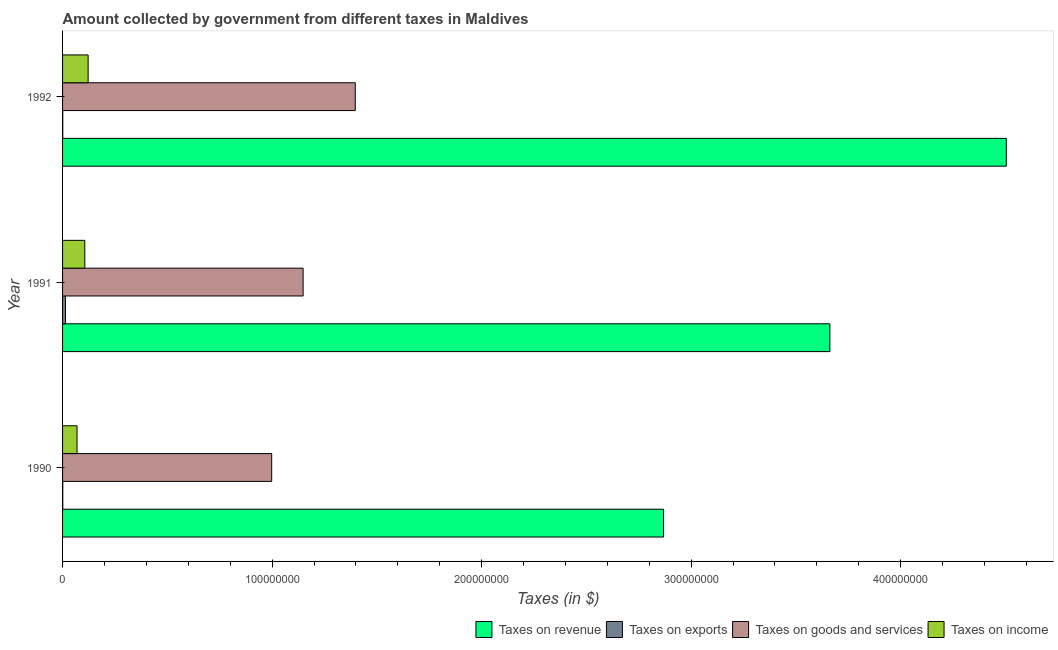How many different coloured bars are there?
Offer a very short reply. 4. How many groups of bars are there?
Your answer should be very brief. 3. Are the number of bars on each tick of the Y-axis equal?
Your answer should be compact. Yes. In how many cases, is the number of bars for a given year not equal to the number of legend labels?
Offer a terse response. 0. What is the amount collected as tax on exports in 1992?
Provide a succinct answer. 1.00e+05. Across all years, what is the maximum amount collected as tax on revenue?
Offer a very short reply. 4.50e+08. Across all years, what is the minimum amount collected as tax on income?
Give a very brief answer. 6.90e+06. What is the total amount collected as tax on revenue in the graph?
Your answer should be very brief. 1.10e+09. What is the difference between the amount collected as tax on goods in 1991 and that in 1992?
Provide a short and direct response. -2.49e+07. What is the difference between the amount collected as tax on revenue in 1991 and the amount collected as tax on income in 1990?
Provide a short and direct response. 3.59e+08. What is the average amount collected as tax on goods per year?
Your answer should be very brief. 1.18e+08. In the year 1992, what is the difference between the amount collected as tax on exports and amount collected as tax on revenue?
Ensure brevity in your answer.  -4.50e+08. In how many years, is the amount collected as tax on exports greater than 260000000 $?
Your answer should be very brief. 0. What is the ratio of the amount collected as tax on goods in 1991 to that in 1992?
Offer a very short reply. 0.82. Is the amount collected as tax on revenue in 1990 less than that in 1991?
Offer a very short reply. Yes. What is the difference between the highest and the second highest amount collected as tax on goods?
Your response must be concise. 2.49e+07. What is the difference between the highest and the lowest amount collected as tax on goods?
Offer a very short reply. 3.99e+07. Is the sum of the amount collected as tax on revenue in 1990 and 1992 greater than the maximum amount collected as tax on goods across all years?
Your answer should be compact. Yes. Is it the case that in every year, the sum of the amount collected as tax on revenue and amount collected as tax on exports is greater than the sum of amount collected as tax on income and amount collected as tax on goods?
Keep it short and to the point. Yes. What does the 2nd bar from the top in 1991 represents?
Your response must be concise. Taxes on goods and services. What does the 3rd bar from the bottom in 1990 represents?
Keep it short and to the point. Taxes on goods and services. Are the values on the major ticks of X-axis written in scientific E-notation?
Offer a terse response. No. Does the graph contain any zero values?
Offer a very short reply. No. Where does the legend appear in the graph?
Offer a terse response. Bottom right. How many legend labels are there?
Offer a terse response. 4. What is the title of the graph?
Give a very brief answer. Amount collected by government from different taxes in Maldives. What is the label or title of the X-axis?
Give a very brief answer. Taxes (in $). What is the Taxes (in $) of Taxes on revenue in 1990?
Keep it short and to the point. 2.87e+08. What is the Taxes (in $) in Taxes on exports in 1990?
Keep it short and to the point. 1.00e+05. What is the Taxes (in $) in Taxes on goods and services in 1990?
Offer a very short reply. 9.98e+07. What is the Taxes (in $) of Taxes on income in 1990?
Keep it short and to the point. 6.90e+06. What is the Taxes (in $) of Taxes on revenue in 1991?
Your answer should be compact. 3.66e+08. What is the Taxes (in $) in Taxes on exports in 1991?
Ensure brevity in your answer.  1.40e+06. What is the Taxes (in $) of Taxes on goods and services in 1991?
Provide a short and direct response. 1.15e+08. What is the Taxes (in $) in Taxes on income in 1991?
Keep it short and to the point. 1.06e+07. What is the Taxes (in $) in Taxes on revenue in 1992?
Your answer should be compact. 4.50e+08. What is the Taxes (in $) of Taxes on goods and services in 1992?
Provide a short and direct response. 1.40e+08. What is the Taxes (in $) of Taxes on income in 1992?
Your response must be concise. 1.22e+07. Across all years, what is the maximum Taxes (in $) of Taxes on revenue?
Make the answer very short. 4.50e+08. Across all years, what is the maximum Taxes (in $) in Taxes on exports?
Provide a short and direct response. 1.40e+06. Across all years, what is the maximum Taxes (in $) in Taxes on goods and services?
Offer a terse response. 1.40e+08. Across all years, what is the maximum Taxes (in $) in Taxes on income?
Provide a succinct answer. 1.22e+07. Across all years, what is the minimum Taxes (in $) of Taxes on revenue?
Offer a very short reply. 2.87e+08. Across all years, what is the minimum Taxes (in $) in Taxes on goods and services?
Make the answer very short. 9.98e+07. Across all years, what is the minimum Taxes (in $) of Taxes on income?
Your answer should be compact. 6.90e+06. What is the total Taxes (in $) in Taxes on revenue in the graph?
Your answer should be very brief. 1.10e+09. What is the total Taxes (in $) in Taxes on exports in the graph?
Offer a very short reply. 1.60e+06. What is the total Taxes (in $) of Taxes on goods and services in the graph?
Make the answer very short. 3.54e+08. What is the total Taxes (in $) in Taxes on income in the graph?
Offer a very short reply. 2.97e+07. What is the difference between the Taxes (in $) in Taxes on revenue in 1990 and that in 1991?
Provide a short and direct response. -7.94e+07. What is the difference between the Taxes (in $) in Taxes on exports in 1990 and that in 1991?
Ensure brevity in your answer.  -1.30e+06. What is the difference between the Taxes (in $) of Taxes on goods and services in 1990 and that in 1991?
Your answer should be very brief. -1.50e+07. What is the difference between the Taxes (in $) of Taxes on income in 1990 and that in 1991?
Give a very brief answer. -3.70e+06. What is the difference between the Taxes (in $) of Taxes on revenue in 1990 and that in 1992?
Your response must be concise. -1.64e+08. What is the difference between the Taxes (in $) of Taxes on goods and services in 1990 and that in 1992?
Offer a terse response. -3.99e+07. What is the difference between the Taxes (in $) of Taxes on income in 1990 and that in 1992?
Offer a very short reply. -5.30e+06. What is the difference between the Taxes (in $) in Taxes on revenue in 1991 and that in 1992?
Ensure brevity in your answer.  -8.42e+07. What is the difference between the Taxes (in $) in Taxes on exports in 1991 and that in 1992?
Provide a short and direct response. 1.30e+06. What is the difference between the Taxes (in $) in Taxes on goods and services in 1991 and that in 1992?
Give a very brief answer. -2.49e+07. What is the difference between the Taxes (in $) of Taxes on income in 1991 and that in 1992?
Ensure brevity in your answer.  -1.60e+06. What is the difference between the Taxes (in $) in Taxes on revenue in 1990 and the Taxes (in $) in Taxes on exports in 1991?
Make the answer very short. 2.85e+08. What is the difference between the Taxes (in $) of Taxes on revenue in 1990 and the Taxes (in $) of Taxes on goods and services in 1991?
Your response must be concise. 1.72e+08. What is the difference between the Taxes (in $) in Taxes on revenue in 1990 and the Taxes (in $) in Taxes on income in 1991?
Give a very brief answer. 2.76e+08. What is the difference between the Taxes (in $) in Taxes on exports in 1990 and the Taxes (in $) in Taxes on goods and services in 1991?
Your answer should be very brief. -1.15e+08. What is the difference between the Taxes (in $) in Taxes on exports in 1990 and the Taxes (in $) in Taxes on income in 1991?
Provide a succinct answer. -1.05e+07. What is the difference between the Taxes (in $) of Taxes on goods and services in 1990 and the Taxes (in $) of Taxes on income in 1991?
Make the answer very short. 8.92e+07. What is the difference between the Taxes (in $) in Taxes on revenue in 1990 and the Taxes (in $) in Taxes on exports in 1992?
Provide a succinct answer. 2.87e+08. What is the difference between the Taxes (in $) of Taxes on revenue in 1990 and the Taxes (in $) of Taxes on goods and services in 1992?
Offer a terse response. 1.47e+08. What is the difference between the Taxes (in $) of Taxes on revenue in 1990 and the Taxes (in $) of Taxes on income in 1992?
Your answer should be compact. 2.75e+08. What is the difference between the Taxes (in $) in Taxes on exports in 1990 and the Taxes (in $) in Taxes on goods and services in 1992?
Make the answer very short. -1.40e+08. What is the difference between the Taxes (in $) of Taxes on exports in 1990 and the Taxes (in $) of Taxes on income in 1992?
Offer a very short reply. -1.21e+07. What is the difference between the Taxes (in $) in Taxes on goods and services in 1990 and the Taxes (in $) in Taxes on income in 1992?
Your answer should be very brief. 8.76e+07. What is the difference between the Taxes (in $) of Taxes on revenue in 1991 and the Taxes (in $) of Taxes on exports in 1992?
Provide a short and direct response. 3.66e+08. What is the difference between the Taxes (in $) of Taxes on revenue in 1991 and the Taxes (in $) of Taxes on goods and services in 1992?
Your answer should be compact. 2.26e+08. What is the difference between the Taxes (in $) in Taxes on revenue in 1991 and the Taxes (in $) in Taxes on income in 1992?
Your answer should be compact. 3.54e+08. What is the difference between the Taxes (in $) of Taxes on exports in 1991 and the Taxes (in $) of Taxes on goods and services in 1992?
Your response must be concise. -1.38e+08. What is the difference between the Taxes (in $) in Taxes on exports in 1991 and the Taxes (in $) in Taxes on income in 1992?
Make the answer very short. -1.08e+07. What is the difference between the Taxes (in $) in Taxes on goods and services in 1991 and the Taxes (in $) in Taxes on income in 1992?
Provide a short and direct response. 1.03e+08. What is the average Taxes (in $) of Taxes on revenue per year?
Offer a terse response. 3.68e+08. What is the average Taxes (in $) in Taxes on exports per year?
Keep it short and to the point. 5.33e+05. What is the average Taxes (in $) in Taxes on goods and services per year?
Your answer should be very brief. 1.18e+08. What is the average Taxes (in $) in Taxes on income per year?
Provide a short and direct response. 9.90e+06. In the year 1990, what is the difference between the Taxes (in $) of Taxes on revenue and Taxes (in $) of Taxes on exports?
Provide a short and direct response. 2.87e+08. In the year 1990, what is the difference between the Taxes (in $) in Taxes on revenue and Taxes (in $) in Taxes on goods and services?
Give a very brief answer. 1.87e+08. In the year 1990, what is the difference between the Taxes (in $) in Taxes on revenue and Taxes (in $) in Taxes on income?
Offer a terse response. 2.80e+08. In the year 1990, what is the difference between the Taxes (in $) of Taxes on exports and Taxes (in $) of Taxes on goods and services?
Your response must be concise. -9.97e+07. In the year 1990, what is the difference between the Taxes (in $) in Taxes on exports and Taxes (in $) in Taxes on income?
Keep it short and to the point. -6.80e+06. In the year 1990, what is the difference between the Taxes (in $) in Taxes on goods and services and Taxes (in $) in Taxes on income?
Offer a very short reply. 9.29e+07. In the year 1991, what is the difference between the Taxes (in $) of Taxes on revenue and Taxes (in $) of Taxes on exports?
Your answer should be very brief. 3.65e+08. In the year 1991, what is the difference between the Taxes (in $) of Taxes on revenue and Taxes (in $) of Taxes on goods and services?
Provide a succinct answer. 2.51e+08. In the year 1991, what is the difference between the Taxes (in $) of Taxes on revenue and Taxes (in $) of Taxes on income?
Offer a very short reply. 3.56e+08. In the year 1991, what is the difference between the Taxes (in $) in Taxes on exports and Taxes (in $) in Taxes on goods and services?
Give a very brief answer. -1.13e+08. In the year 1991, what is the difference between the Taxes (in $) in Taxes on exports and Taxes (in $) in Taxes on income?
Provide a short and direct response. -9.20e+06. In the year 1991, what is the difference between the Taxes (in $) in Taxes on goods and services and Taxes (in $) in Taxes on income?
Ensure brevity in your answer.  1.04e+08. In the year 1992, what is the difference between the Taxes (in $) of Taxes on revenue and Taxes (in $) of Taxes on exports?
Your response must be concise. 4.50e+08. In the year 1992, what is the difference between the Taxes (in $) in Taxes on revenue and Taxes (in $) in Taxes on goods and services?
Your response must be concise. 3.11e+08. In the year 1992, what is the difference between the Taxes (in $) in Taxes on revenue and Taxes (in $) in Taxes on income?
Your answer should be compact. 4.38e+08. In the year 1992, what is the difference between the Taxes (in $) in Taxes on exports and Taxes (in $) in Taxes on goods and services?
Offer a very short reply. -1.40e+08. In the year 1992, what is the difference between the Taxes (in $) of Taxes on exports and Taxes (in $) of Taxes on income?
Provide a short and direct response. -1.21e+07. In the year 1992, what is the difference between the Taxes (in $) of Taxes on goods and services and Taxes (in $) of Taxes on income?
Your answer should be compact. 1.28e+08. What is the ratio of the Taxes (in $) of Taxes on revenue in 1990 to that in 1991?
Offer a terse response. 0.78. What is the ratio of the Taxes (in $) of Taxes on exports in 1990 to that in 1991?
Your response must be concise. 0.07. What is the ratio of the Taxes (in $) in Taxes on goods and services in 1990 to that in 1991?
Your answer should be compact. 0.87. What is the ratio of the Taxes (in $) of Taxes on income in 1990 to that in 1991?
Give a very brief answer. 0.65. What is the ratio of the Taxes (in $) of Taxes on revenue in 1990 to that in 1992?
Provide a short and direct response. 0.64. What is the ratio of the Taxes (in $) in Taxes on goods and services in 1990 to that in 1992?
Your answer should be compact. 0.71. What is the ratio of the Taxes (in $) in Taxes on income in 1990 to that in 1992?
Your answer should be compact. 0.57. What is the ratio of the Taxes (in $) of Taxes on revenue in 1991 to that in 1992?
Offer a terse response. 0.81. What is the ratio of the Taxes (in $) in Taxes on goods and services in 1991 to that in 1992?
Offer a very short reply. 0.82. What is the ratio of the Taxes (in $) of Taxes on income in 1991 to that in 1992?
Make the answer very short. 0.87. What is the difference between the highest and the second highest Taxes (in $) in Taxes on revenue?
Your response must be concise. 8.42e+07. What is the difference between the highest and the second highest Taxes (in $) in Taxes on exports?
Keep it short and to the point. 1.30e+06. What is the difference between the highest and the second highest Taxes (in $) of Taxes on goods and services?
Keep it short and to the point. 2.49e+07. What is the difference between the highest and the second highest Taxes (in $) of Taxes on income?
Ensure brevity in your answer.  1.60e+06. What is the difference between the highest and the lowest Taxes (in $) in Taxes on revenue?
Provide a succinct answer. 1.64e+08. What is the difference between the highest and the lowest Taxes (in $) in Taxes on exports?
Give a very brief answer. 1.30e+06. What is the difference between the highest and the lowest Taxes (in $) in Taxes on goods and services?
Your answer should be very brief. 3.99e+07. What is the difference between the highest and the lowest Taxes (in $) in Taxes on income?
Ensure brevity in your answer.  5.30e+06. 